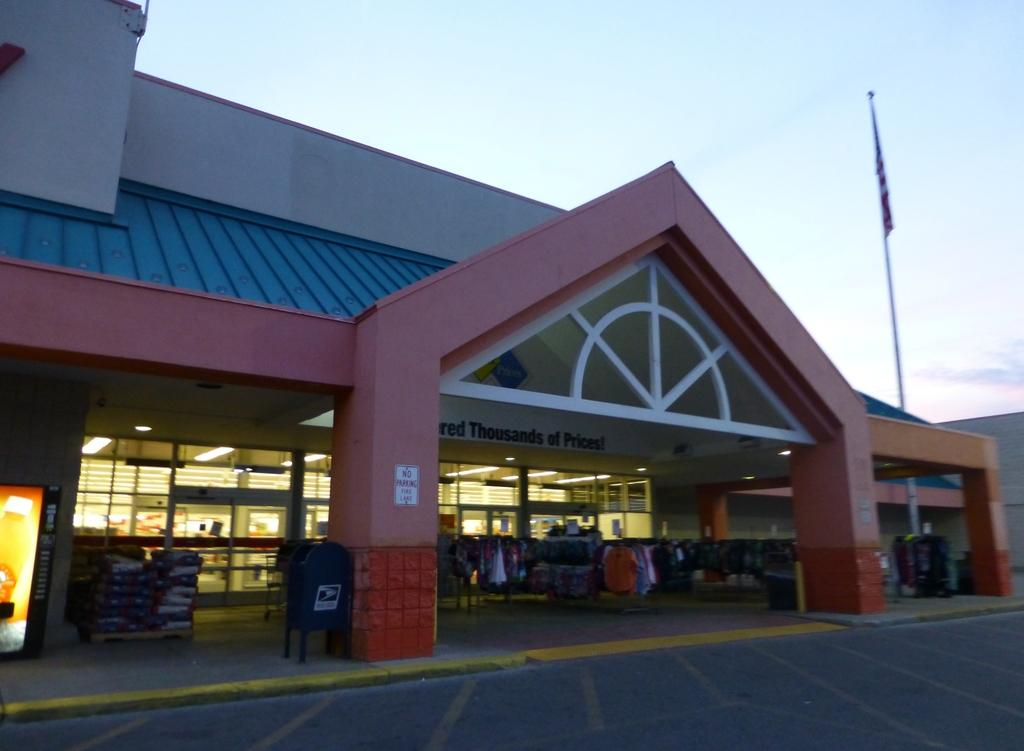What type of structure is present in the image? There is a house in the image. What else can be seen in the image besides the house? Clothes, a screen, and a flag are visible in the image. What is the condition of the sky in the image? The sky is visible at the top of the image. What type of yarn is being used to create the flag in the image? There is no yarn present in the image; the flag is already made. What kind of jewel can be seen on the screen in the image? There is no jewel visible on the screen in the image. 